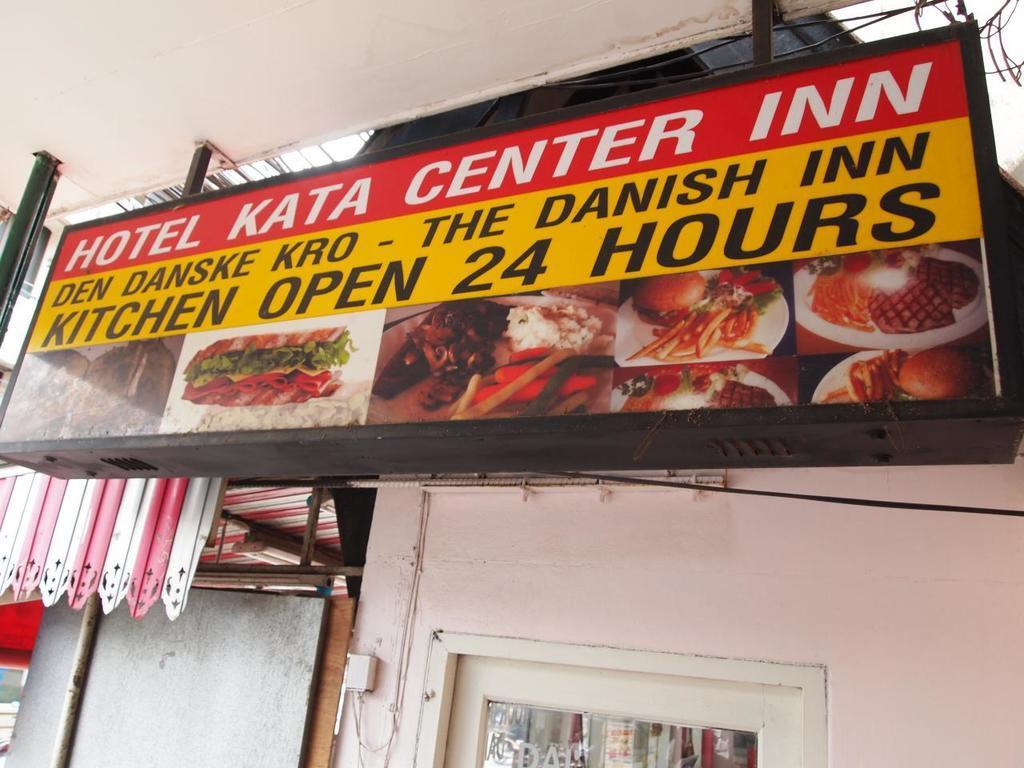Please provide a concise description of this image. In this image there is a hoarding in the middle. At the bottom there is a wall to which there is a window. 